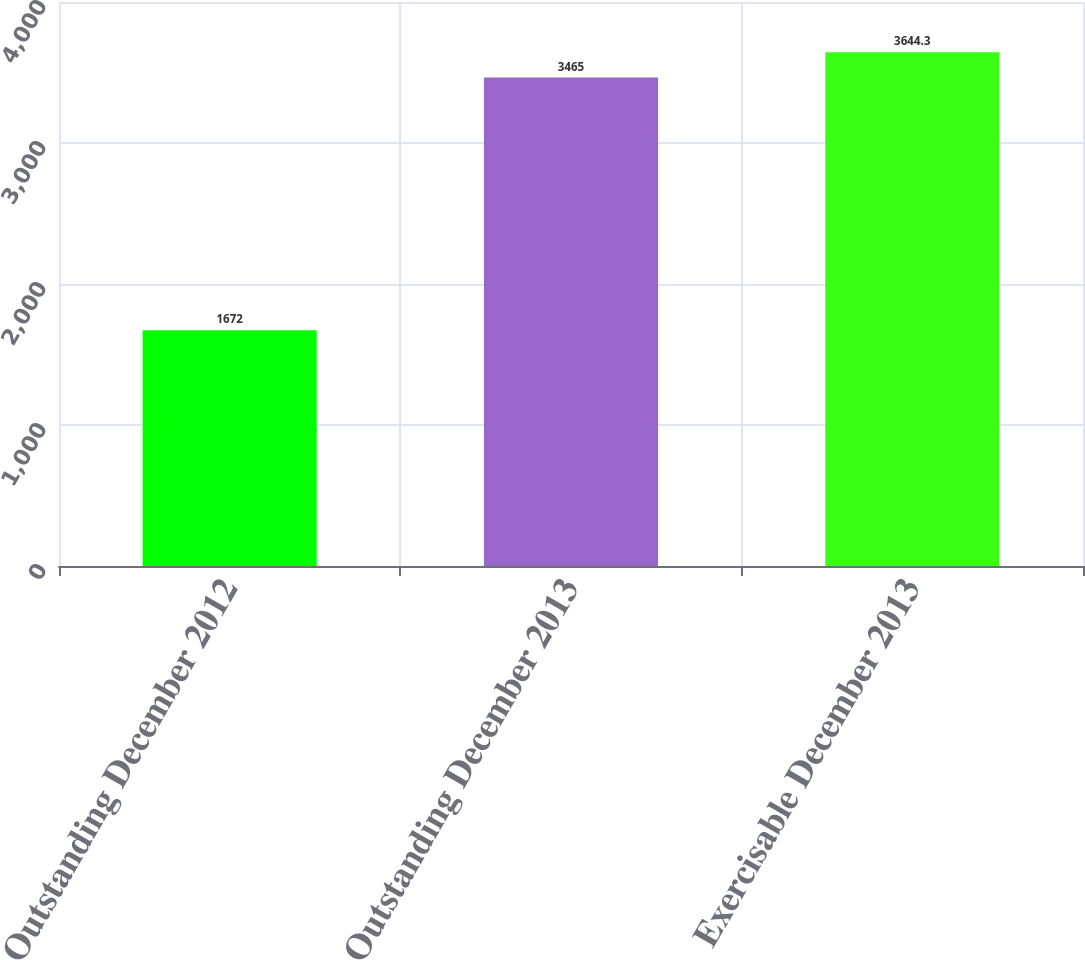Convert chart to OTSL. <chart><loc_0><loc_0><loc_500><loc_500><bar_chart><fcel>Outstanding December 2012<fcel>Outstanding December 2013<fcel>Exercisable December 2013<nl><fcel>1672<fcel>3465<fcel>3644.3<nl></chart> 